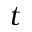<formula> <loc_0><loc_0><loc_500><loc_500>t</formula> 